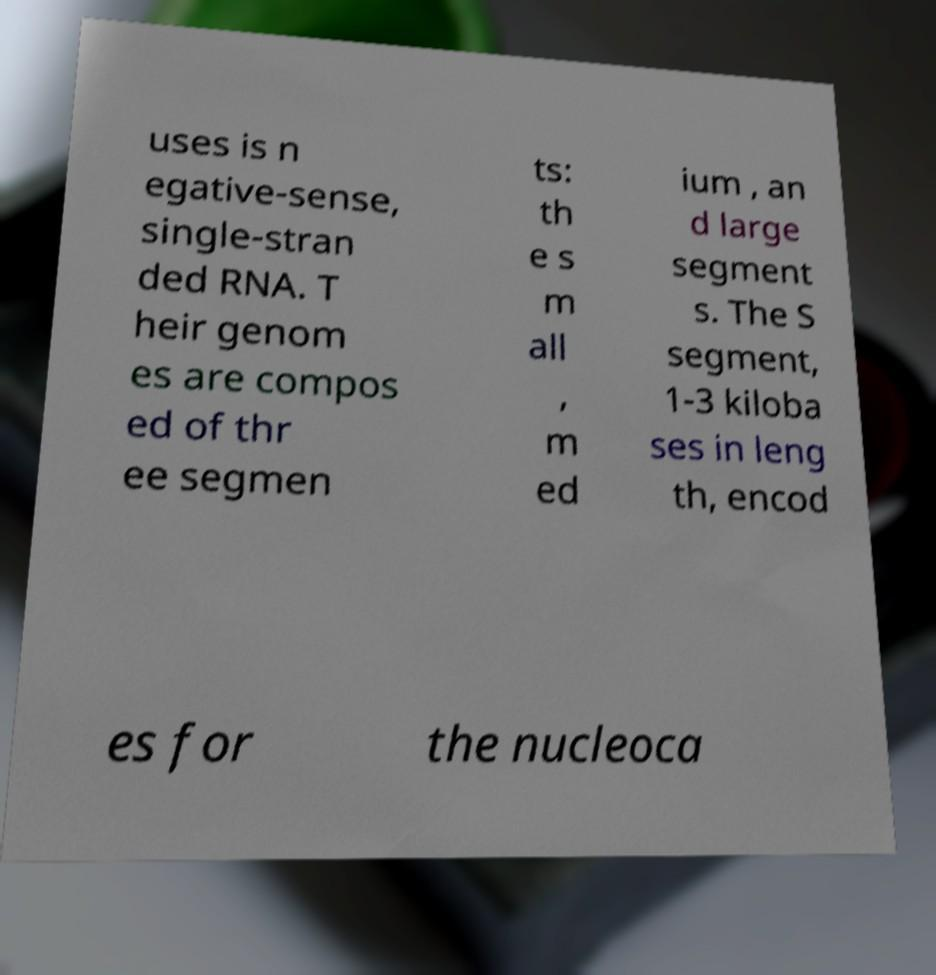Can you read and provide the text displayed in the image?This photo seems to have some interesting text. Can you extract and type it out for me? uses is n egative-sense, single-stran ded RNA. T heir genom es are compos ed of thr ee segmen ts: th e s m all , m ed ium , an d large segment s. The S segment, 1-3 kiloba ses in leng th, encod es for the nucleoca 